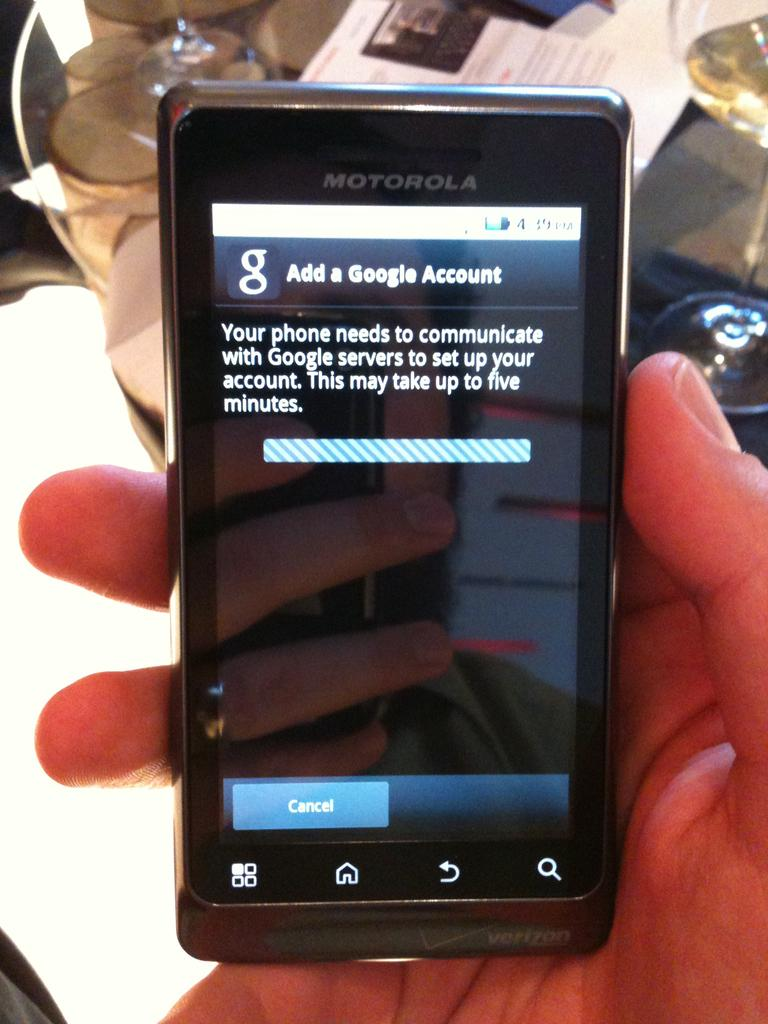<image>
Write a terse but informative summary of the picture. A Motorola phone is showing a screen where the person can add a Google account. 